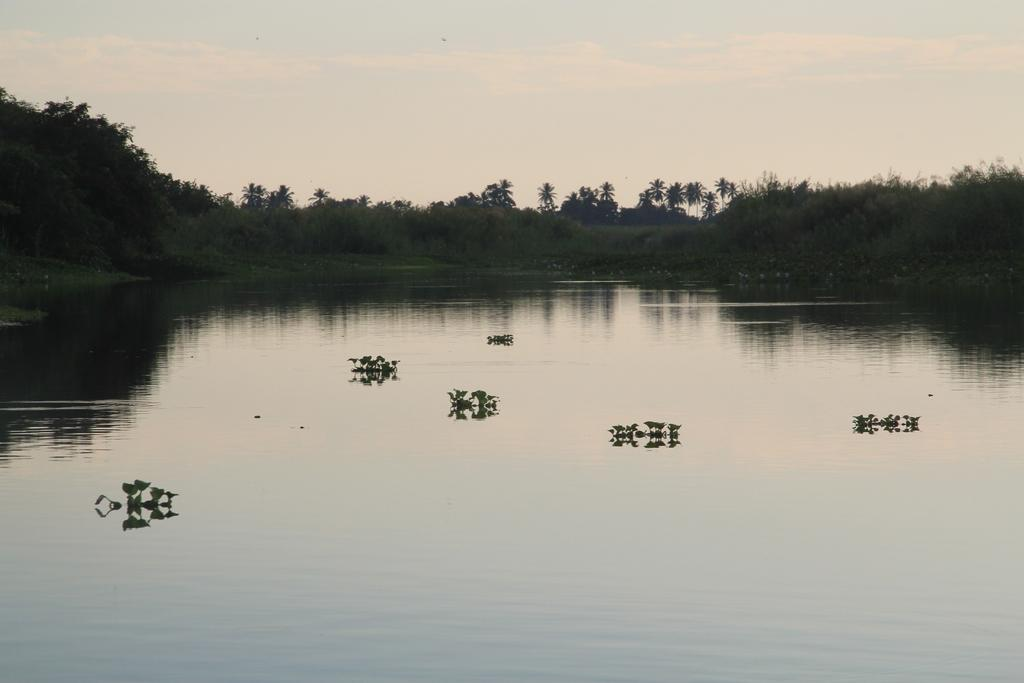What is located at the bottom of the image? There are plants and water at the bottom of the image. What can be seen in the background of the image? There are trees, grass, and the sky visible in the background of the image. What is the condition of the sky in the image? The sky is visible in the background of the image, and there are clouds present. What type of spoon is being used to catch the clouds in the image? There is no spoon present in the image, and the clouds are not being caught. What thought process is depicted in the image? There is no thought process depicted in the image; it features plants, water, trees, grass, and clouds. 